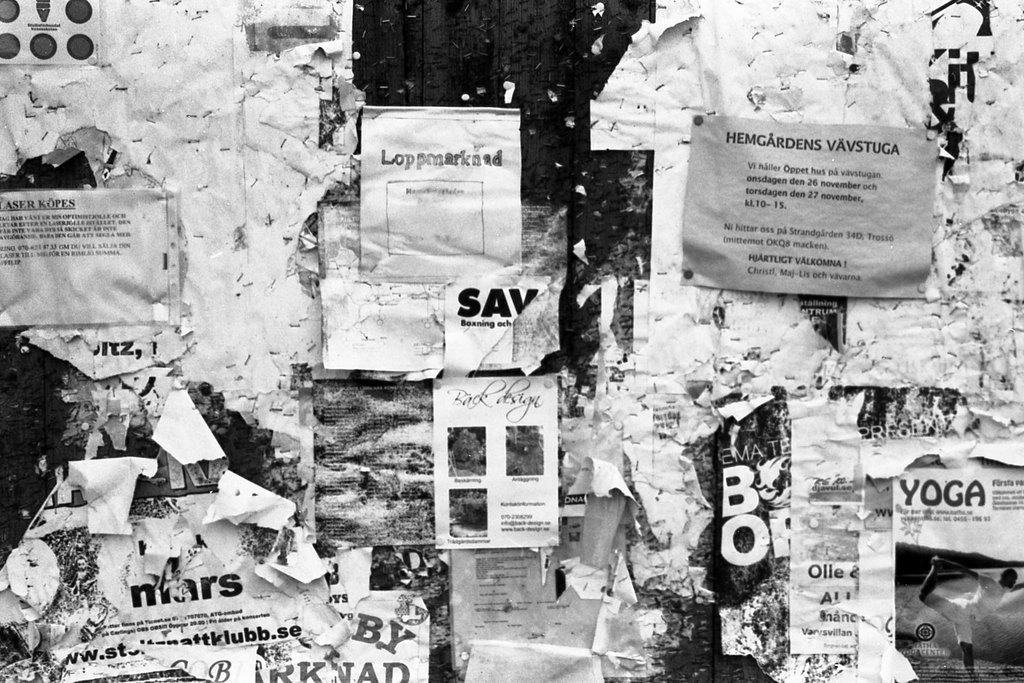What objects are present in the image? There are posts in the image. How are the posts connected to something else? The posts are attached to a surface. What color scheme is used in the image? The image is black and white. How many geese are seen dropping breakfast items in the image? There are no geese or breakfast items present in the image. 